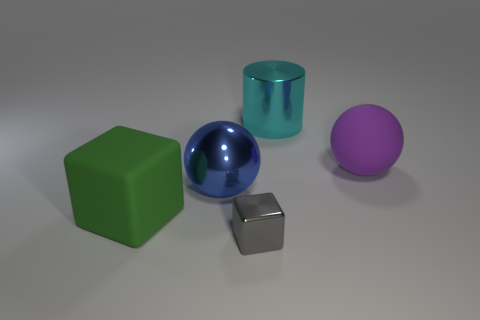Are the object that is in front of the large matte cube and the big ball that is on the left side of the large purple sphere made of the same material?
Your answer should be very brief. Yes. How many large green things are the same shape as the small gray thing?
Make the answer very short. 1. What number of objects are big metal cylinders or objects to the right of the cyan metallic cylinder?
Your answer should be compact. 2. What is the material of the green cube?
Keep it short and to the point. Rubber. What material is the other thing that is the same shape as the big blue metallic object?
Provide a short and direct response. Rubber. What color is the matte thing in front of the thing that is on the right side of the cyan cylinder?
Your answer should be very brief. Green. What number of metal objects are either green cubes or tiny red blocks?
Offer a very short reply. 0. Are the blue thing and the large green cube made of the same material?
Your answer should be very brief. No. What is the material of the sphere that is behind the big ball on the left side of the big cyan shiny thing?
Your answer should be compact. Rubber. How many big objects are either cylinders or purple rubber objects?
Your answer should be compact. 2. 